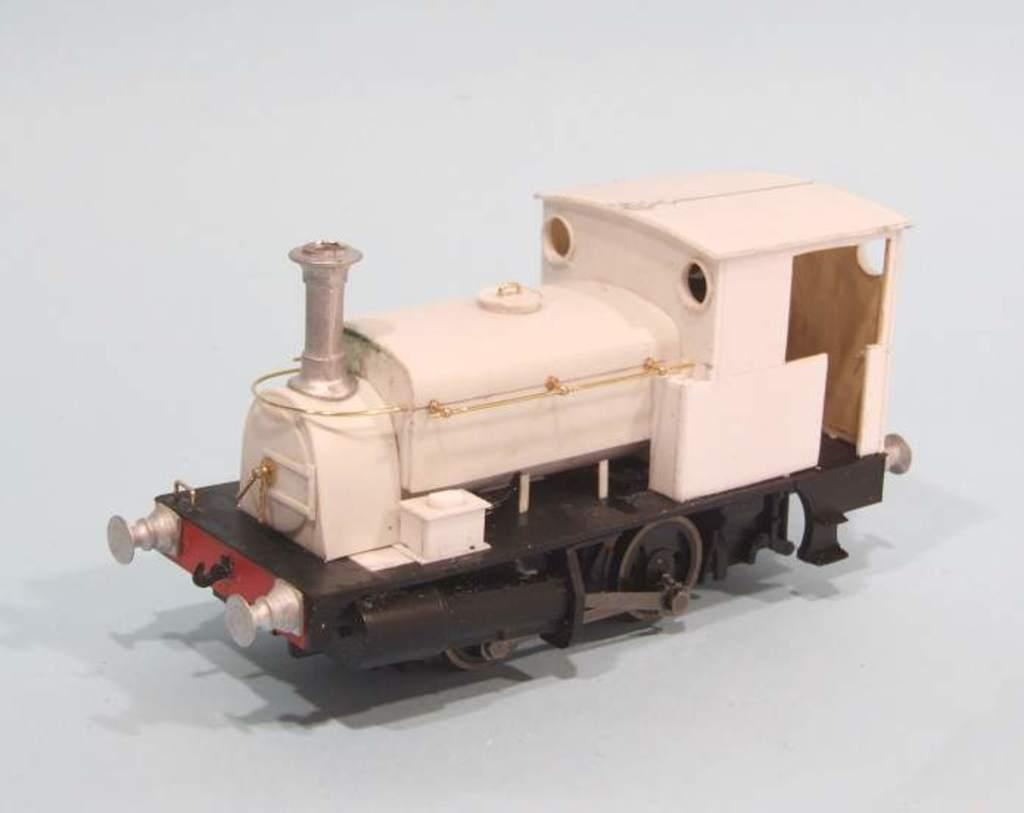What is the main subject of the image? The main subject of the image is a toy train. What type of milk is being used for teaching in the office in the image? There is no milk, teaching, or office present in the image; it features a toy train. 